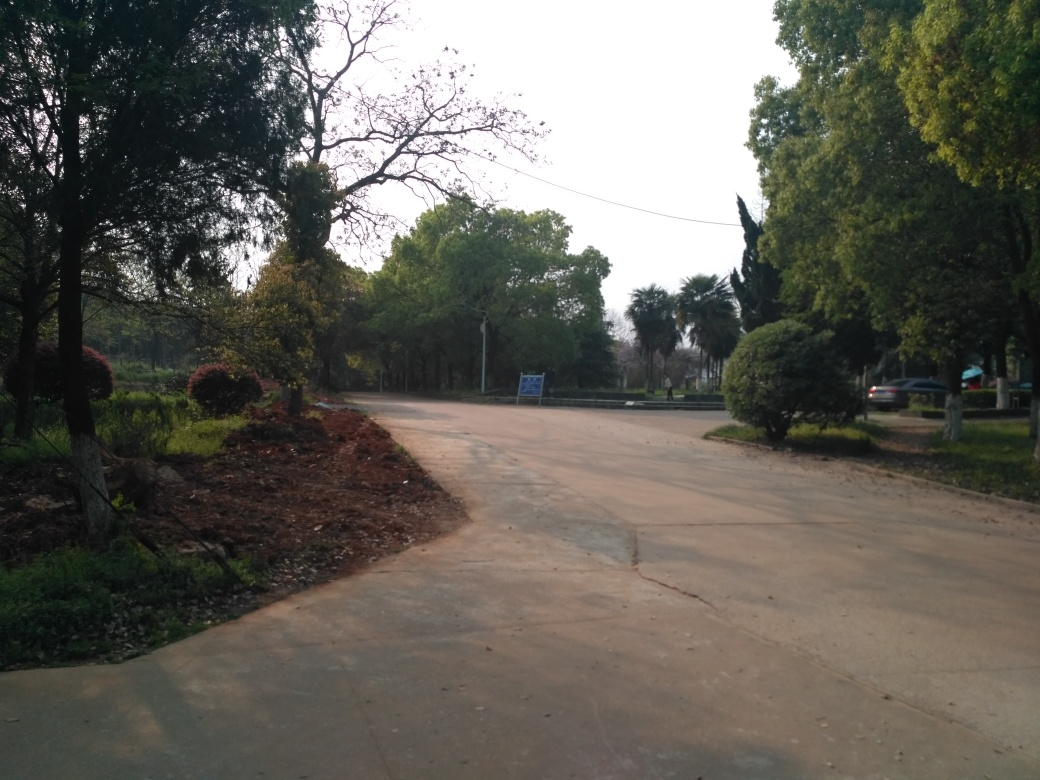What time of day does this image seem to be captured? Judging by the lighting and the length of the shadows, it seems like the image was taken either in the early morning or late afternoon. The sun is not directly overhead, and the gentle lighting suggests times of day when the sun is lower on the horizon. Are there any activities you think could take place in this area? Given the peaceful setting, activities like walking, jogging, picnicking, or casual cycling could be enjoyable here. The area might also be used for quieter leisure activities such as reading, meditating, or simply enjoying the natural surroundings. 